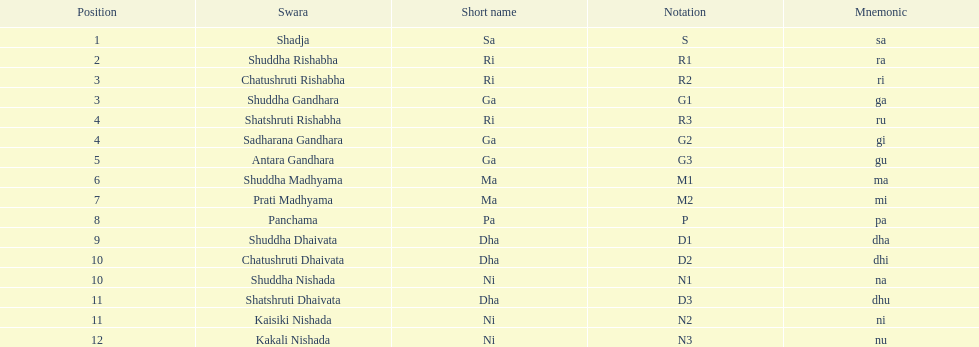What is the name of the swara that holds the first position? Shadja. 